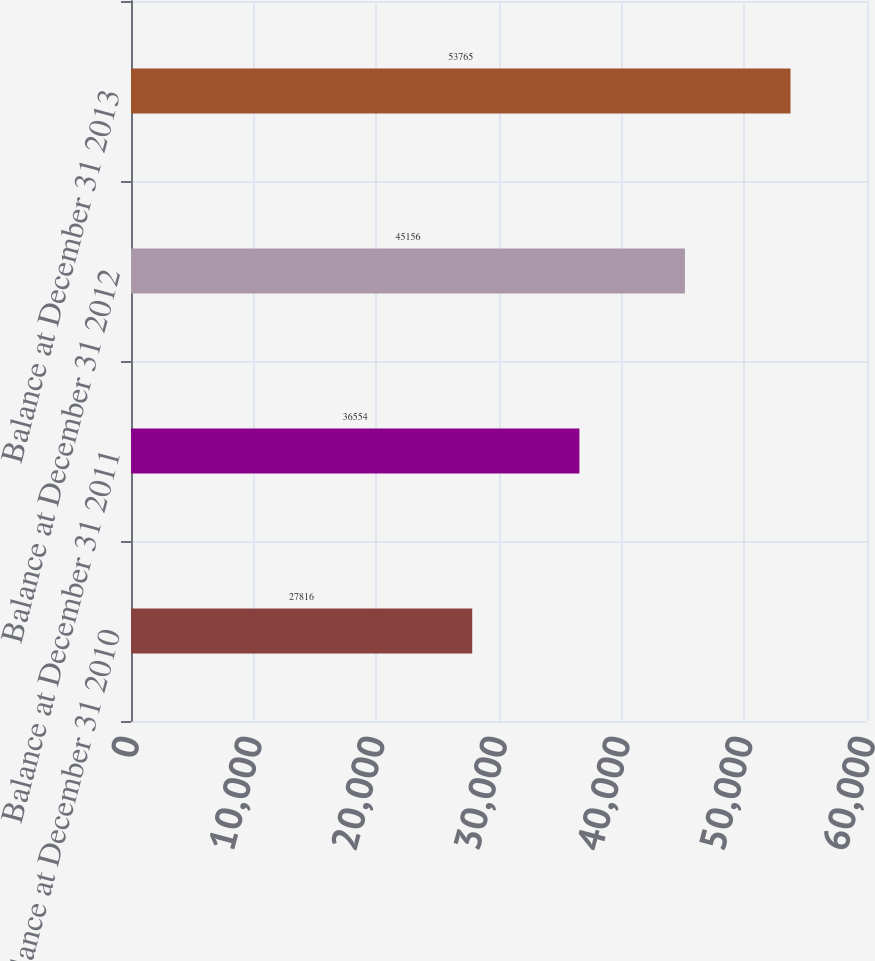<chart> <loc_0><loc_0><loc_500><loc_500><bar_chart><fcel>Balance at December 31 2010<fcel>Balance at December 31 2011<fcel>Balance at December 31 2012<fcel>Balance at December 31 2013<nl><fcel>27816<fcel>36554<fcel>45156<fcel>53765<nl></chart> 